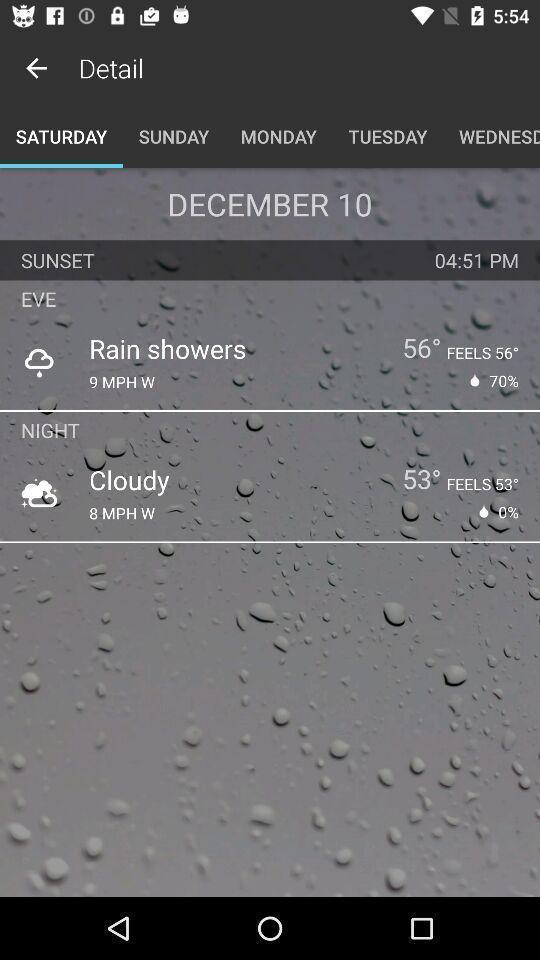Describe the key features of this screenshot. Screen shows the details of weather forecasts. 